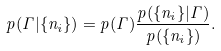Convert formula to latex. <formula><loc_0><loc_0><loc_500><loc_500>p ( \Gamma | \{ n _ { i } \} ) = p ( \Gamma ) \frac { p ( \{ n _ { i } \} | \Gamma ) } { p ( \{ n _ { i } \} ) } .</formula> 